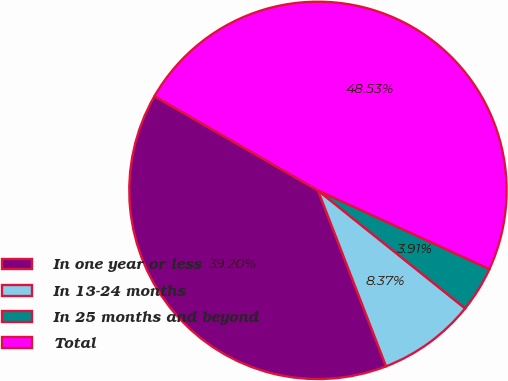<chart> <loc_0><loc_0><loc_500><loc_500><pie_chart><fcel>In one year or less<fcel>In 13-24 months<fcel>In 25 months and beyond<fcel>Total<nl><fcel>39.2%<fcel>8.37%<fcel>3.91%<fcel>48.53%<nl></chart> 